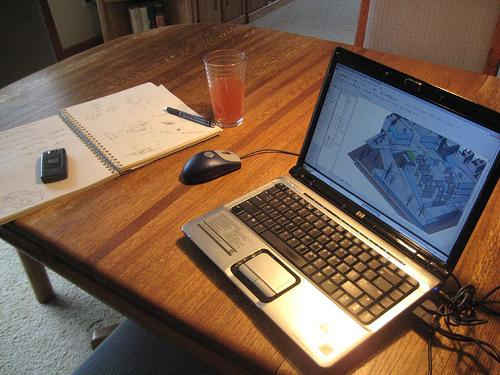What is the computer most at risk of?

Choices:
A) flood hazard
B) hail hazard
C) fire hazard
D) lightning hazard fire hazard 